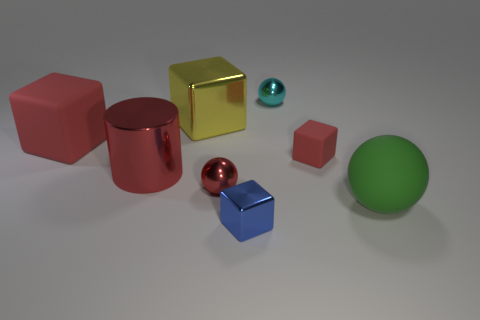Subtract all red cylinders. How many red blocks are left? 2 Subtract all shiny spheres. How many spheres are left? 1 Subtract 2 blocks. How many blocks are left? 2 Subtract all yellow cubes. How many cubes are left? 3 Subtract all purple cubes. Subtract all red cylinders. How many cubes are left? 4 Add 2 big green matte objects. How many objects exist? 10 Subtract all balls. How many objects are left? 5 Subtract all small yellow rubber blocks. Subtract all blue cubes. How many objects are left? 7 Add 4 cyan spheres. How many cyan spheres are left? 5 Add 3 matte cylinders. How many matte cylinders exist? 3 